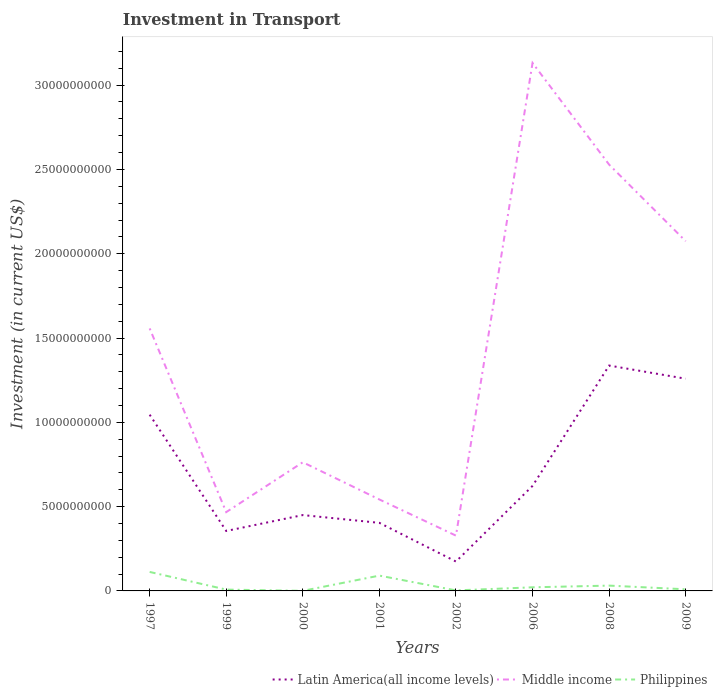How many different coloured lines are there?
Give a very brief answer. 3. Does the line corresponding to Middle income intersect with the line corresponding to Latin America(all income levels)?
Provide a succinct answer. No. Is the number of lines equal to the number of legend labels?
Provide a succinct answer. Yes. Across all years, what is the maximum amount invested in transport in Philippines?
Offer a terse response. 4.90e+06. In which year was the amount invested in transport in Middle income maximum?
Provide a succinct answer. 2002. What is the total amount invested in transport in Philippines in the graph?
Offer a very short reply. 2.18e+08. What is the difference between the highest and the second highest amount invested in transport in Middle income?
Offer a terse response. 2.80e+1. How many years are there in the graph?
Your response must be concise. 8. Are the values on the major ticks of Y-axis written in scientific E-notation?
Offer a terse response. No. Does the graph contain any zero values?
Make the answer very short. No. How many legend labels are there?
Give a very brief answer. 3. How are the legend labels stacked?
Provide a short and direct response. Horizontal. What is the title of the graph?
Make the answer very short. Investment in Transport. Does "Latin America(all income levels)" appear as one of the legend labels in the graph?
Keep it short and to the point. Yes. What is the label or title of the X-axis?
Your answer should be very brief. Years. What is the label or title of the Y-axis?
Your response must be concise. Investment (in current US$). What is the Investment (in current US$) of Latin America(all income levels) in 1997?
Make the answer very short. 1.05e+1. What is the Investment (in current US$) in Middle income in 1997?
Ensure brevity in your answer.  1.56e+1. What is the Investment (in current US$) in Philippines in 1997?
Offer a terse response. 1.13e+09. What is the Investment (in current US$) in Latin America(all income levels) in 1999?
Make the answer very short. 3.56e+09. What is the Investment (in current US$) of Middle income in 1999?
Provide a succinct answer. 4.67e+09. What is the Investment (in current US$) in Philippines in 1999?
Offer a terse response. 7.83e+07. What is the Investment (in current US$) in Latin America(all income levels) in 2000?
Offer a very short reply. 4.50e+09. What is the Investment (in current US$) in Middle income in 2000?
Ensure brevity in your answer.  7.63e+09. What is the Investment (in current US$) in Philippines in 2000?
Offer a terse response. 4.90e+06. What is the Investment (in current US$) of Latin America(all income levels) in 2001?
Give a very brief answer. 4.04e+09. What is the Investment (in current US$) of Middle income in 2001?
Make the answer very short. 5.42e+09. What is the Investment (in current US$) of Philippines in 2001?
Offer a very short reply. 9.08e+08. What is the Investment (in current US$) in Latin America(all income levels) in 2002?
Ensure brevity in your answer.  1.74e+09. What is the Investment (in current US$) in Middle income in 2002?
Offer a terse response. 3.28e+09. What is the Investment (in current US$) of Philippines in 2002?
Provide a succinct answer. 3.01e+07. What is the Investment (in current US$) of Latin America(all income levels) in 2006?
Ensure brevity in your answer.  6.23e+09. What is the Investment (in current US$) of Middle income in 2006?
Keep it short and to the point. 3.13e+1. What is the Investment (in current US$) of Philippines in 2006?
Provide a short and direct response. 2.15e+08. What is the Investment (in current US$) in Latin America(all income levels) in 2008?
Offer a very short reply. 1.34e+1. What is the Investment (in current US$) in Middle income in 2008?
Keep it short and to the point. 2.53e+1. What is the Investment (in current US$) of Philippines in 2008?
Provide a short and direct response. 3.15e+08. What is the Investment (in current US$) in Latin America(all income levels) in 2009?
Offer a very short reply. 1.26e+1. What is the Investment (in current US$) of Middle income in 2009?
Keep it short and to the point. 2.07e+1. What is the Investment (in current US$) of Philippines in 2009?
Your answer should be compact. 9.60e+07. Across all years, what is the maximum Investment (in current US$) of Latin America(all income levels)?
Offer a terse response. 1.34e+1. Across all years, what is the maximum Investment (in current US$) in Middle income?
Give a very brief answer. 3.13e+1. Across all years, what is the maximum Investment (in current US$) of Philippines?
Provide a short and direct response. 1.13e+09. Across all years, what is the minimum Investment (in current US$) of Latin America(all income levels)?
Your answer should be very brief. 1.74e+09. Across all years, what is the minimum Investment (in current US$) in Middle income?
Your response must be concise. 3.28e+09. Across all years, what is the minimum Investment (in current US$) of Philippines?
Give a very brief answer. 4.90e+06. What is the total Investment (in current US$) in Latin America(all income levels) in the graph?
Offer a very short reply. 5.65e+1. What is the total Investment (in current US$) in Middle income in the graph?
Offer a terse response. 1.14e+11. What is the total Investment (in current US$) in Philippines in the graph?
Your answer should be compact. 2.77e+09. What is the difference between the Investment (in current US$) in Latin America(all income levels) in 1997 and that in 1999?
Ensure brevity in your answer.  6.90e+09. What is the difference between the Investment (in current US$) of Middle income in 1997 and that in 1999?
Ensure brevity in your answer.  1.09e+1. What is the difference between the Investment (in current US$) of Philippines in 1997 and that in 1999?
Give a very brief answer. 1.05e+09. What is the difference between the Investment (in current US$) in Latin America(all income levels) in 1997 and that in 2000?
Make the answer very short. 5.95e+09. What is the difference between the Investment (in current US$) of Middle income in 1997 and that in 2000?
Provide a succinct answer. 7.94e+09. What is the difference between the Investment (in current US$) of Philippines in 1997 and that in 2000?
Offer a very short reply. 1.12e+09. What is the difference between the Investment (in current US$) of Latin America(all income levels) in 1997 and that in 2001?
Keep it short and to the point. 6.42e+09. What is the difference between the Investment (in current US$) of Middle income in 1997 and that in 2001?
Keep it short and to the point. 1.01e+1. What is the difference between the Investment (in current US$) in Philippines in 1997 and that in 2001?
Ensure brevity in your answer.  2.18e+08. What is the difference between the Investment (in current US$) of Latin America(all income levels) in 1997 and that in 2002?
Make the answer very short. 8.71e+09. What is the difference between the Investment (in current US$) in Middle income in 1997 and that in 2002?
Your response must be concise. 1.23e+1. What is the difference between the Investment (in current US$) of Philippines in 1997 and that in 2002?
Offer a very short reply. 1.10e+09. What is the difference between the Investment (in current US$) of Latin America(all income levels) in 1997 and that in 2006?
Give a very brief answer. 4.22e+09. What is the difference between the Investment (in current US$) in Middle income in 1997 and that in 2006?
Keep it short and to the point. -1.57e+1. What is the difference between the Investment (in current US$) of Philippines in 1997 and that in 2006?
Your answer should be compact. 9.12e+08. What is the difference between the Investment (in current US$) in Latin America(all income levels) in 1997 and that in 2008?
Ensure brevity in your answer.  -2.91e+09. What is the difference between the Investment (in current US$) of Middle income in 1997 and that in 2008?
Your answer should be very brief. -9.72e+09. What is the difference between the Investment (in current US$) of Philippines in 1997 and that in 2008?
Your answer should be very brief. 8.11e+08. What is the difference between the Investment (in current US$) of Latin America(all income levels) in 1997 and that in 2009?
Provide a succinct answer. -2.13e+09. What is the difference between the Investment (in current US$) in Middle income in 1997 and that in 2009?
Ensure brevity in your answer.  -5.18e+09. What is the difference between the Investment (in current US$) in Philippines in 1997 and that in 2009?
Your answer should be compact. 1.03e+09. What is the difference between the Investment (in current US$) of Latin America(all income levels) in 1999 and that in 2000?
Make the answer very short. -9.42e+08. What is the difference between the Investment (in current US$) of Middle income in 1999 and that in 2000?
Offer a very short reply. -2.96e+09. What is the difference between the Investment (in current US$) of Philippines in 1999 and that in 2000?
Your response must be concise. 7.34e+07. What is the difference between the Investment (in current US$) of Latin America(all income levels) in 1999 and that in 2001?
Offer a terse response. -4.81e+08. What is the difference between the Investment (in current US$) of Middle income in 1999 and that in 2001?
Offer a terse response. -7.49e+08. What is the difference between the Investment (in current US$) in Philippines in 1999 and that in 2001?
Provide a succinct answer. -8.30e+08. What is the difference between the Investment (in current US$) in Latin America(all income levels) in 1999 and that in 2002?
Ensure brevity in your answer.  1.81e+09. What is the difference between the Investment (in current US$) in Middle income in 1999 and that in 2002?
Make the answer very short. 1.40e+09. What is the difference between the Investment (in current US$) of Philippines in 1999 and that in 2002?
Make the answer very short. 4.82e+07. What is the difference between the Investment (in current US$) in Latin America(all income levels) in 1999 and that in 2006?
Offer a very short reply. -2.67e+09. What is the difference between the Investment (in current US$) of Middle income in 1999 and that in 2006?
Keep it short and to the point. -2.66e+1. What is the difference between the Investment (in current US$) of Philippines in 1999 and that in 2006?
Provide a succinct answer. -1.36e+08. What is the difference between the Investment (in current US$) in Latin America(all income levels) in 1999 and that in 2008?
Make the answer very short. -9.81e+09. What is the difference between the Investment (in current US$) of Middle income in 1999 and that in 2008?
Make the answer very short. -2.06e+1. What is the difference between the Investment (in current US$) in Philippines in 1999 and that in 2008?
Make the answer very short. -2.37e+08. What is the difference between the Investment (in current US$) of Latin America(all income levels) in 1999 and that in 2009?
Your answer should be very brief. -9.03e+09. What is the difference between the Investment (in current US$) in Middle income in 1999 and that in 2009?
Make the answer very short. -1.61e+1. What is the difference between the Investment (in current US$) of Philippines in 1999 and that in 2009?
Give a very brief answer. -1.77e+07. What is the difference between the Investment (in current US$) of Latin America(all income levels) in 2000 and that in 2001?
Ensure brevity in your answer.  4.62e+08. What is the difference between the Investment (in current US$) in Middle income in 2000 and that in 2001?
Your answer should be very brief. 2.21e+09. What is the difference between the Investment (in current US$) of Philippines in 2000 and that in 2001?
Offer a terse response. -9.04e+08. What is the difference between the Investment (in current US$) of Latin America(all income levels) in 2000 and that in 2002?
Your answer should be compact. 2.76e+09. What is the difference between the Investment (in current US$) of Middle income in 2000 and that in 2002?
Ensure brevity in your answer.  4.35e+09. What is the difference between the Investment (in current US$) in Philippines in 2000 and that in 2002?
Offer a very short reply. -2.52e+07. What is the difference between the Investment (in current US$) in Latin America(all income levels) in 2000 and that in 2006?
Make the answer very short. -1.73e+09. What is the difference between the Investment (in current US$) of Middle income in 2000 and that in 2006?
Provide a succinct answer. -2.37e+1. What is the difference between the Investment (in current US$) in Philippines in 2000 and that in 2006?
Keep it short and to the point. -2.10e+08. What is the difference between the Investment (in current US$) of Latin America(all income levels) in 2000 and that in 2008?
Your answer should be very brief. -8.87e+09. What is the difference between the Investment (in current US$) in Middle income in 2000 and that in 2008?
Your answer should be compact. -1.77e+1. What is the difference between the Investment (in current US$) of Philippines in 2000 and that in 2008?
Ensure brevity in your answer.  -3.10e+08. What is the difference between the Investment (in current US$) in Latin America(all income levels) in 2000 and that in 2009?
Make the answer very short. -8.09e+09. What is the difference between the Investment (in current US$) of Middle income in 2000 and that in 2009?
Give a very brief answer. -1.31e+1. What is the difference between the Investment (in current US$) of Philippines in 2000 and that in 2009?
Give a very brief answer. -9.11e+07. What is the difference between the Investment (in current US$) in Latin America(all income levels) in 2001 and that in 2002?
Your answer should be very brief. 2.29e+09. What is the difference between the Investment (in current US$) in Middle income in 2001 and that in 2002?
Offer a terse response. 2.14e+09. What is the difference between the Investment (in current US$) in Philippines in 2001 and that in 2002?
Give a very brief answer. 8.78e+08. What is the difference between the Investment (in current US$) of Latin America(all income levels) in 2001 and that in 2006?
Give a very brief answer. -2.19e+09. What is the difference between the Investment (in current US$) of Middle income in 2001 and that in 2006?
Give a very brief answer. -2.59e+1. What is the difference between the Investment (in current US$) in Philippines in 2001 and that in 2006?
Keep it short and to the point. 6.94e+08. What is the difference between the Investment (in current US$) in Latin America(all income levels) in 2001 and that in 2008?
Offer a terse response. -9.33e+09. What is the difference between the Investment (in current US$) of Middle income in 2001 and that in 2008?
Provide a succinct answer. -1.99e+1. What is the difference between the Investment (in current US$) of Philippines in 2001 and that in 2008?
Your response must be concise. 5.93e+08. What is the difference between the Investment (in current US$) in Latin America(all income levels) in 2001 and that in 2009?
Make the answer very short. -8.55e+09. What is the difference between the Investment (in current US$) in Middle income in 2001 and that in 2009?
Offer a terse response. -1.53e+1. What is the difference between the Investment (in current US$) of Philippines in 2001 and that in 2009?
Give a very brief answer. 8.12e+08. What is the difference between the Investment (in current US$) in Latin America(all income levels) in 2002 and that in 2006?
Your response must be concise. -4.49e+09. What is the difference between the Investment (in current US$) in Middle income in 2002 and that in 2006?
Your answer should be very brief. -2.80e+1. What is the difference between the Investment (in current US$) of Philippines in 2002 and that in 2006?
Make the answer very short. -1.84e+08. What is the difference between the Investment (in current US$) of Latin America(all income levels) in 2002 and that in 2008?
Offer a very short reply. -1.16e+1. What is the difference between the Investment (in current US$) of Middle income in 2002 and that in 2008?
Ensure brevity in your answer.  -2.20e+1. What is the difference between the Investment (in current US$) in Philippines in 2002 and that in 2008?
Keep it short and to the point. -2.85e+08. What is the difference between the Investment (in current US$) of Latin America(all income levels) in 2002 and that in 2009?
Your response must be concise. -1.08e+1. What is the difference between the Investment (in current US$) in Middle income in 2002 and that in 2009?
Ensure brevity in your answer.  -1.75e+1. What is the difference between the Investment (in current US$) of Philippines in 2002 and that in 2009?
Ensure brevity in your answer.  -6.59e+07. What is the difference between the Investment (in current US$) in Latin America(all income levels) in 2006 and that in 2008?
Provide a succinct answer. -7.14e+09. What is the difference between the Investment (in current US$) of Middle income in 2006 and that in 2008?
Make the answer very short. 6.03e+09. What is the difference between the Investment (in current US$) of Philippines in 2006 and that in 2008?
Your answer should be compact. -1.01e+08. What is the difference between the Investment (in current US$) of Latin America(all income levels) in 2006 and that in 2009?
Provide a succinct answer. -6.36e+09. What is the difference between the Investment (in current US$) of Middle income in 2006 and that in 2009?
Your answer should be very brief. 1.06e+1. What is the difference between the Investment (in current US$) of Philippines in 2006 and that in 2009?
Your answer should be very brief. 1.19e+08. What is the difference between the Investment (in current US$) of Latin America(all income levels) in 2008 and that in 2009?
Offer a terse response. 7.81e+08. What is the difference between the Investment (in current US$) in Middle income in 2008 and that in 2009?
Offer a terse response. 4.54e+09. What is the difference between the Investment (in current US$) of Philippines in 2008 and that in 2009?
Provide a succinct answer. 2.19e+08. What is the difference between the Investment (in current US$) in Latin America(all income levels) in 1997 and the Investment (in current US$) in Middle income in 1999?
Keep it short and to the point. 5.78e+09. What is the difference between the Investment (in current US$) of Latin America(all income levels) in 1997 and the Investment (in current US$) of Philippines in 1999?
Provide a succinct answer. 1.04e+1. What is the difference between the Investment (in current US$) in Middle income in 1997 and the Investment (in current US$) in Philippines in 1999?
Your answer should be compact. 1.55e+1. What is the difference between the Investment (in current US$) in Latin America(all income levels) in 1997 and the Investment (in current US$) in Middle income in 2000?
Offer a very short reply. 2.82e+09. What is the difference between the Investment (in current US$) in Latin America(all income levels) in 1997 and the Investment (in current US$) in Philippines in 2000?
Offer a terse response. 1.04e+1. What is the difference between the Investment (in current US$) of Middle income in 1997 and the Investment (in current US$) of Philippines in 2000?
Make the answer very short. 1.56e+1. What is the difference between the Investment (in current US$) of Latin America(all income levels) in 1997 and the Investment (in current US$) of Middle income in 2001?
Your response must be concise. 5.03e+09. What is the difference between the Investment (in current US$) of Latin America(all income levels) in 1997 and the Investment (in current US$) of Philippines in 2001?
Your answer should be compact. 9.54e+09. What is the difference between the Investment (in current US$) of Middle income in 1997 and the Investment (in current US$) of Philippines in 2001?
Keep it short and to the point. 1.47e+1. What is the difference between the Investment (in current US$) in Latin America(all income levels) in 1997 and the Investment (in current US$) in Middle income in 2002?
Offer a very short reply. 7.17e+09. What is the difference between the Investment (in current US$) in Latin America(all income levels) in 1997 and the Investment (in current US$) in Philippines in 2002?
Your answer should be compact. 1.04e+1. What is the difference between the Investment (in current US$) in Middle income in 1997 and the Investment (in current US$) in Philippines in 2002?
Your answer should be very brief. 1.55e+1. What is the difference between the Investment (in current US$) in Latin America(all income levels) in 1997 and the Investment (in current US$) in Middle income in 2006?
Make the answer very short. -2.09e+1. What is the difference between the Investment (in current US$) of Latin America(all income levels) in 1997 and the Investment (in current US$) of Philippines in 2006?
Your response must be concise. 1.02e+1. What is the difference between the Investment (in current US$) in Middle income in 1997 and the Investment (in current US$) in Philippines in 2006?
Make the answer very short. 1.54e+1. What is the difference between the Investment (in current US$) in Latin America(all income levels) in 1997 and the Investment (in current US$) in Middle income in 2008?
Give a very brief answer. -1.48e+1. What is the difference between the Investment (in current US$) in Latin America(all income levels) in 1997 and the Investment (in current US$) in Philippines in 2008?
Make the answer very short. 1.01e+1. What is the difference between the Investment (in current US$) of Middle income in 1997 and the Investment (in current US$) of Philippines in 2008?
Provide a short and direct response. 1.53e+1. What is the difference between the Investment (in current US$) in Latin America(all income levels) in 1997 and the Investment (in current US$) in Middle income in 2009?
Your answer should be compact. -1.03e+1. What is the difference between the Investment (in current US$) in Latin America(all income levels) in 1997 and the Investment (in current US$) in Philippines in 2009?
Give a very brief answer. 1.04e+1. What is the difference between the Investment (in current US$) of Middle income in 1997 and the Investment (in current US$) of Philippines in 2009?
Your response must be concise. 1.55e+1. What is the difference between the Investment (in current US$) in Latin America(all income levels) in 1999 and the Investment (in current US$) in Middle income in 2000?
Make the answer very short. -4.07e+09. What is the difference between the Investment (in current US$) of Latin America(all income levels) in 1999 and the Investment (in current US$) of Philippines in 2000?
Make the answer very short. 3.55e+09. What is the difference between the Investment (in current US$) in Middle income in 1999 and the Investment (in current US$) in Philippines in 2000?
Your answer should be compact. 4.67e+09. What is the difference between the Investment (in current US$) of Latin America(all income levels) in 1999 and the Investment (in current US$) of Middle income in 2001?
Provide a succinct answer. -1.87e+09. What is the difference between the Investment (in current US$) of Latin America(all income levels) in 1999 and the Investment (in current US$) of Philippines in 2001?
Your answer should be compact. 2.65e+09. What is the difference between the Investment (in current US$) in Middle income in 1999 and the Investment (in current US$) in Philippines in 2001?
Give a very brief answer. 3.77e+09. What is the difference between the Investment (in current US$) in Latin America(all income levels) in 1999 and the Investment (in current US$) in Middle income in 2002?
Ensure brevity in your answer.  2.78e+08. What is the difference between the Investment (in current US$) of Latin America(all income levels) in 1999 and the Investment (in current US$) of Philippines in 2002?
Ensure brevity in your answer.  3.53e+09. What is the difference between the Investment (in current US$) of Middle income in 1999 and the Investment (in current US$) of Philippines in 2002?
Your response must be concise. 4.64e+09. What is the difference between the Investment (in current US$) in Latin America(all income levels) in 1999 and the Investment (in current US$) in Middle income in 2006?
Keep it short and to the point. -2.78e+1. What is the difference between the Investment (in current US$) of Latin America(all income levels) in 1999 and the Investment (in current US$) of Philippines in 2006?
Keep it short and to the point. 3.34e+09. What is the difference between the Investment (in current US$) in Middle income in 1999 and the Investment (in current US$) in Philippines in 2006?
Your answer should be very brief. 4.46e+09. What is the difference between the Investment (in current US$) of Latin America(all income levels) in 1999 and the Investment (in current US$) of Middle income in 2008?
Make the answer very short. -2.17e+1. What is the difference between the Investment (in current US$) in Latin America(all income levels) in 1999 and the Investment (in current US$) in Philippines in 2008?
Provide a short and direct response. 3.24e+09. What is the difference between the Investment (in current US$) of Middle income in 1999 and the Investment (in current US$) of Philippines in 2008?
Give a very brief answer. 4.36e+09. What is the difference between the Investment (in current US$) of Latin America(all income levels) in 1999 and the Investment (in current US$) of Middle income in 2009?
Offer a terse response. -1.72e+1. What is the difference between the Investment (in current US$) in Latin America(all income levels) in 1999 and the Investment (in current US$) in Philippines in 2009?
Offer a very short reply. 3.46e+09. What is the difference between the Investment (in current US$) in Middle income in 1999 and the Investment (in current US$) in Philippines in 2009?
Provide a short and direct response. 4.58e+09. What is the difference between the Investment (in current US$) of Latin America(all income levels) in 2000 and the Investment (in current US$) of Middle income in 2001?
Provide a succinct answer. -9.25e+08. What is the difference between the Investment (in current US$) of Latin America(all income levels) in 2000 and the Investment (in current US$) of Philippines in 2001?
Make the answer very short. 3.59e+09. What is the difference between the Investment (in current US$) of Middle income in 2000 and the Investment (in current US$) of Philippines in 2001?
Your response must be concise. 6.72e+09. What is the difference between the Investment (in current US$) in Latin America(all income levels) in 2000 and the Investment (in current US$) in Middle income in 2002?
Give a very brief answer. 1.22e+09. What is the difference between the Investment (in current US$) in Latin America(all income levels) in 2000 and the Investment (in current US$) in Philippines in 2002?
Your answer should be compact. 4.47e+09. What is the difference between the Investment (in current US$) of Middle income in 2000 and the Investment (in current US$) of Philippines in 2002?
Provide a short and direct response. 7.60e+09. What is the difference between the Investment (in current US$) of Latin America(all income levels) in 2000 and the Investment (in current US$) of Middle income in 2006?
Provide a short and direct response. -2.68e+1. What is the difference between the Investment (in current US$) of Latin America(all income levels) in 2000 and the Investment (in current US$) of Philippines in 2006?
Offer a very short reply. 4.28e+09. What is the difference between the Investment (in current US$) in Middle income in 2000 and the Investment (in current US$) in Philippines in 2006?
Your answer should be very brief. 7.42e+09. What is the difference between the Investment (in current US$) in Latin America(all income levels) in 2000 and the Investment (in current US$) in Middle income in 2008?
Your response must be concise. -2.08e+1. What is the difference between the Investment (in current US$) in Latin America(all income levels) in 2000 and the Investment (in current US$) in Philippines in 2008?
Your answer should be very brief. 4.18e+09. What is the difference between the Investment (in current US$) of Middle income in 2000 and the Investment (in current US$) of Philippines in 2008?
Offer a terse response. 7.32e+09. What is the difference between the Investment (in current US$) in Latin America(all income levels) in 2000 and the Investment (in current US$) in Middle income in 2009?
Your response must be concise. -1.62e+1. What is the difference between the Investment (in current US$) of Latin America(all income levels) in 2000 and the Investment (in current US$) of Philippines in 2009?
Your response must be concise. 4.40e+09. What is the difference between the Investment (in current US$) in Middle income in 2000 and the Investment (in current US$) in Philippines in 2009?
Give a very brief answer. 7.53e+09. What is the difference between the Investment (in current US$) in Latin America(all income levels) in 2001 and the Investment (in current US$) in Middle income in 2002?
Provide a short and direct response. 7.58e+08. What is the difference between the Investment (in current US$) in Latin America(all income levels) in 2001 and the Investment (in current US$) in Philippines in 2002?
Your answer should be compact. 4.01e+09. What is the difference between the Investment (in current US$) of Middle income in 2001 and the Investment (in current US$) of Philippines in 2002?
Give a very brief answer. 5.39e+09. What is the difference between the Investment (in current US$) of Latin America(all income levels) in 2001 and the Investment (in current US$) of Middle income in 2006?
Your response must be concise. -2.73e+1. What is the difference between the Investment (in current US$) in Latin America(all income levels) in 2001 and the Investment (in current US$) in Philippines in 2006?
Your answer should be compact. 3.82e+09. What is the difference between the Investment (in current US$) in Middle income in 2001 and the Investment (in current US$) in Philippines in 2006?
Your answer should be compact. 5.21e+09. What is the difference between the Investment (in current US$) of Latin America(all income levels) in 2001 and the Investment (in current US$) of Middle income in 2008?
Give a very brief answer. -2.12e+1. What is the difference between the Investment (in current US$) of Latin America(all income levels) in 2001 and the Investment (in current US$) of Philippines in 2008?
Provide a succinct answer. 3.72e+09. What is the difference between the Investment (in current US$) in Middle income in 2001 and the Investment (in current US$) in Philippines in 2008?
Give a very brief answer. 5.11e+09. What is the difference between the Investment (in current US$) of Latin America(all income levels) in 2001 and the Investment (in current US$) of Middle income in 2009?
Keep it short and to the point. -1.67e+1. What is the difference between the Investment (in current US$) in Latin America(all income levels) in 2001 and the Investment (in current US$) in Philippines in 2009?
Give a very brief answer. 3.94e+09. What is the difference between the Investment (in current US$) of Middle income in 2001 and the Investment (in current US$) of Philippines in 2009?
Your response must be concise. 5.33e+09. What is the difference between the Investment (in current US$) in Latin America(all income levels) in 2002 and the Investment (in current US$) in Middle income in 2006?
Your answer should be very brief. -2.96e+1. What is the difference between the Investment (in current US$) of Latin America(all income levels) in 2002 and the Investment (in current US$) of Philippines in 2006?
Offer a very short reply. 1.53e+09. What is the difference between the Investment (in current US$) of Middle income in 2002 and the Investment (in current US$) of Philippines in 2006?
Provide a succinct answer. 3.06e+09. What is the difference between the Investment (in current US$) in Latin America(all income levels) in 2002 and the Investment (in current US$) in Middle income in 2008?
Give a very brief answer. -2.35e+1. What is the difference between the Investment (in current US$) in Latin America(all income levels) in 2002 and the Investment (in current US$) in Philippines in 2008?
Your response must be concise. 1.43e+09. What is the difference between the Investment (in current US$) of Middle income in 2002 and the Investment (in current US$) of Philippines in 2008?
Your response must be concise. 2.96e+09. What is the difference between the Investment (in current US$) of Latin America(all income levels) in 2002 and the Investment (in current US$) of Middle income in 2009?
Your answer should be very brief. -1.90e+1. What is the difference between the Investment (in current US$) in Latin America(all income levels) in 2002 and the Investment (in current US$) in Philippines in 2009?
Ensure brevity in your answer.  1.65e+09. What is the difference between the Investment (in current US$) of Middle income in 2002 and the Investment (in current US$) of Philippines in 2009?
Your answer should be very brief. 3.18e+09. What is the difference between the Investment (in current US$) in Latin America(all income levels) in 2006 and the Investment (in current US$) in Middle income in 2008?
Your response must be concise. -1.91e+1. What is the difference between the Investment (in current US$) in Latin America(all income levels) in 2006 and the Investment (in current US$) in Philippines in 2008?
Your answer should be very brief. 5.91e+09. What is the difference between the Investment (in current US$) in Middle income in 2006 and the Investment (in current US$) in Philippines in 2008?
Offer a very short reply. 3.10e+1. What is the difference between the Investment (in current US$) of Latin America(all income levels) in 2006 and the Investment (in current US$) of Middle income in 2009?
Ensure brevity in your answer.  -1.45e+1. What is the difference between the Investment (in current US$) of Latin America(all income levels) in 2006 and the Investment (in current US$) of Philippines in 2009?
Make the answer very short. 6.13e+09. What is the difference between the Investment (in current US$) of Middle income in 2006 and the Investment (in current US$) of Philippines in 2009?
Your answer should be compact. 3.12e+1. What is the difference between the Investment (in current US$) of Latin America(all income levels) in 2008 and the Investment (in current US$) of Middle income in 2009?
Offer a terse response. -7.38e+09. What is the difference between the Investment (in current US$) in Latin America(all income levels) in 2008 and the Investment (in current US$) in Philippines in 2009?
Ensure brevity in your answer.  1.33e+1. What is the difference between the Investment (in current US$) in Middle income in 2008 and the Investment (in current US$) in Philippines in 2009?
Your response must be concise. 2.52e+1. What is the average Investment (in current US$) in Latin America(all income levels) per year?
Ensure brevity in your answer.  7.06e+09. What is the average Investment (in current US$) in Middle income per year?
Provide a short and direct response. 1.42e+1. What is the average Investment (in current US$) of Philippines per year?
Keep it short and to the point. 3.47e+08. In the year 1997, what is the difference between the Investment (in current US$) in Latin America(all income levels) and Investment (in current US$) in Middle income?
Your answer should be compact. -5.12e+09. In the year 1997, what is the difference between the Investment (in current US$) of Latin America(all income levels) and Investment (in current US$) of Philippines?
Your response must be concise. 9.33e+09. In the year 1997, what is the difference between the Investment (in current US$) in Middle income and Investment (in current US$) in Philippines?
Keep it short and to the point. 1.44e+1. In the year 1999, what is the difference between the Investment (in current US$) in Latin America(all income levels) and Investment (in current US$) in Middle income?
Provide a short and direct response. -1.12e+09. In the year 1999, what is the difference between the Investment (in current US$) of Latin America(all income levels) and Investment (in current US$) of Philippines?
Ensure brevity in your answer.  3.48e+09. In the year 1999, what is the difference between the Investment (in current US$) of Middle income and Investment (in current US$) of Philippines?
Offer a terse response. 4.60e+09. In the year 2000, what is the difference between the Investment (in current US$) of Latin America(all income levels) and Investment (in current US$) of Middle income?
Offer a terse response. -3.13e+09. In the year 2000, what is the difference between the Investment (in current US$) of Latin America(all income levels) and Investment (in current US$) of Philippines?
Your response must be concise. 4.49e+09. In the year 2000, what is the difference between the Investment (in current US$) of Middle income and Investment (in current US$) of Philippines?
Make the answer very short. 7.63e+09. In the year 2001, what is the difference between the Investment (in current US$) in Latin America(all income levels) and Investment (in current US$) in Middle income?
Provide a succinct answer. -1.39e+09. In the year 2001, what is the difference between the Investment (in current US$) in Latin America(all income levels) and Investment (in current US$) in Philippines?
Keep it short and to the point. 3.13e+09. In the year 2001, what is the difference between the Investment (in current US$) in Middle income and Investment (in current US$) in Philippines?
Keep it short and to the point. 4.52e+09. In the year 2002, what is the difference between the Investment (in current US$) of Latin America(all income levels) and Investment (in current US$) of Middle income?
Provide a succinct answer. -1.54e+09. In the year 2002, what is the difference between the Investment (in current US$) of Latin America(all income levels) and Investment (in current US$) of Philippines?
Keep it short and to the point. 1.71e+09. In the year 2002, what is the difference between the Investment (in current US$) of Middle income and Investment (in current US$) of Philippines?
Your answer should be compact. 3.25e+09. In the year 2006, what is the difference between the Investment (in current US$) of Latin America(all income levels) and Investment (in current US$) of Middle income?
Keep it short and to the point. -2.51e+1. In the year 2006, what is the difference between the Investment (in current US$) of Latin America(all income levels) and Investment (in current US$) of Philippines?
Your answer should be very brief. 6.02e+09. In the year 2006, what is the difference between the Investment (in current US$) in Middle income and Investment (in current US$) in Philippines?
Ensure brevity in your answer.  3.11e+1. In the year 2008, what is the difference between the Investment (in current US$) in Latin America(all income levels) and Investment (in current US$) in Middle income?
Offer a very short reply. -1.19e+1. In the year 2008, what is the difference between the Investment (in current US$) of Latin America(all income levels) and Investment (in current US$) of Philippines?
Make the answer very short. 1.31e+1. In the year 2008, what is the difference between the Investment (in current US$) of Middle income and Investment (in current US$) of Philippines?
Offer a very short reply. 2.50e+1. In the year 2009, what is the difference between the Investment (in current US$) in Latin America(all income levels) and Investment (in current US$) in Middle income?
Provide a short and direct response. -8.16e+09. In the year 2009, what is the difference between the Investment (in current US$) of Latin America(all income levels) and Investment (in current US$) of Philippines?
Offer a very short reply. 1.25e+1. In the year 2009, what is the difference between the Investment (in current US$) of Middle income and Investment (in current US$) of Philippines?
Offer a very short reply. 2.06e+1. What is the ratio of the Investment (in current US$) of Latin America(all income levels) in 1997 to that in 1999?
Provide a succinct answer. 2.94. What is the ratio of the Investment (in current US$) of Middle income in 1997 to that in 1999?
Provide a succinct answer. 3.33. What is the ratio of the Investment (in current US$) in Philippines in 1997 to that in 1999?
Make the answer very short. 14.39. What is the ratio of the Investment (in current US$) in Latin America(all income levels) in 1997 to that in 2000?
Your response must be concise. 2.32. What is the ratio of the Investment (in current US$) of Middle income in 1997 to that in 2000?
Provide a succinct answer. 2.04. What is the ratio of the Investment (in current US$) of Philippines in 1997 to that in 2000?
Provide a succinct answer. 229.94. What is the ratio of the Investment (in current US$) of Latin America(all income levels) in 1997 to that in 2001?
Ensure brevity in your answer.  2.59. What is the ratio of the Investment (in current US$) in Middle income in 1997 to that in 2001?
Keep it short and to the point. 2.87. What is the ratio of the Investment (in current US$) in Philippines in 1997 to that in 2001?
Your response must be concise. 1.24. What is the ratio of the Investment (in current US$) in Latin America(all income levels) in 1997 to that in 2002?
Provide a succinct answer. 6. What is the ratio of the Investment (in current US$) in Middle income in 1997 to that in 2002?
Make the answer very short. 4.75. What is the ratio of the Investment (in current US$) of Philippines in 1997 to that in 2002?
Provide a short and direct response. 37.43. What is the ratio of the Investment (in current US$) in Latin America(all income levels) in 1997 to that in 2006?
Provide a succinct answer. 1.68. What is the ratio of the Investment (in current US$) of Middle income in 1997 to that in 2006?
Give a very brief answer. 0.5. What is the ratio of the Investment (in current US$) in Philippines in 1997 to that in 2006?
Your answer should be very brief. 5.25. What is the ratio of the Investment (in current US$) of Latin America(all income levels) in 1997 to that in 2008?
Your answer should be compact. 0.78. What is the ratio of the Investment (in current US$) of Middle income in 1997 to that in 2008?
Your answer should be compact. 0.62. What is the ratio of the Investment (in current US$) of Philippines in 1997 to that in 2008?
Ensure brevity in your answer.  3.57. What is the ratio of the Investment (in current US$) in Latin America(all income levels) in 1997 to that in 2009?
Provide a succinct answer. 0.83. What is the ratio of the Investment (in current US$) of Middle income in 1997 to that in 2009?
Keep it short and to the point. 0.75. What is the ratio of the Investment (in current US$) of Philippines in 1997 to that in 2009?
Provide a short and direct response. 11.74. What is the ratio of the Investment (in current US$) of Latin America(all income levels) in 1999 to that in 2000?
Make the answer very short. 0.79. What is the ratio of the Investment (in current US$) of Middle income in 1999 to that in 2000?
Keep it short and to the point. 0.61. What is the ratio of the Investment (in current US$) in Philippines in 1999 to that in 2000?
Provide a short and direct response. 15.98. What is the ratio of the Investment (in current US$) of Latin America(all income levels) in 1999 to that in 2001?
Offer a very short reply. 0.88. What is the ratio of the Investment (in current US$) in Middle income in 1999 to that in 2001?
Provide a short and direct response. 0.86. What is the ratio of the Investment (in current US$) in Philippines in 1999 to that in 2001?
Provide a succinct answer. 0.09. What is the ratio of the Investment (in current US$) in Latin America(all income levels) in 1999 to that in 2002?
Your answer should be compact. 2.04. What is the ratio of the Investment (in current US$) of Middle income in 1999 to that in 2002?
Offer a terse response. 1.43. What is the ratio of the Investment (in current US$) of Philippines in 1999 to that in 2002?
Your answer should be compact. 2.6. What is the ratio of the Investment (in current US$) of Latin America(all income levels) in 1999 to that in 2006?
Provide a succinct answer. 0.57. What is the ratio of the Investment (in current US$) of Middle income in 1999 to that in 2006?
Keep it short and to the point. 0.15. What is the ratio of the Investment (in current US$) in Philippines in 1999 to that in 2006?
Your response must be concise. 0.36. What is the ratio of the Investment (in current US$) of Latin America(all income levels) in 1999 to that in 2008?
Your answer should be very brief. 0.27. What is the ratio of the Investment (in current US$) in Middle income in 1999 to that in 2008?
Offer a very short reply. 0.18. What is the ratio of the Investment (in current US$) in Philippines in 1999 to that in 2008?
Provide a short and direct response. 0.25. What is the ratio of the Investment (in current US$) of Latin America(all income levels) in 1999 to that in 2009?
Give a very brief answer. 0.28. What is the ratio of the Investment (in current US$) in Middle income in 1999 to that in 2009?
Your answer should be compact. 0.23. What is the ratio of the Investment (in current US$) in Philippines in 1999 to that in 2009?
Your answer should be compact. 0.82. What is the ratio of the Investment (in current US$) of Latin America(all income levels) in 2000 to that in 2001?
Your response must be concise. 1.11. What is the ratio of the Investment (in current US$) of Middle income in 2000 to that in 2001?
Provide a short and direct response. 1.41. What is the ratio of the Investment (in current US$) of Philippines in 2000 to that in 2001?
Provide a succinct answer. 0.01. What is the ratio of the Investment (in current US$) of Latin America(all income levels) in 2000 to that in 2002?
Keep it short and to the point. 2.58. What is the ratio of the Investment (in current US$) in Middle income in 2000 to that in 2002?
Offer a very short reply. 2.33. What is the ratio of the Investment (in current US$) in Philippines in 2000 to that in 2002?
Provide a succinct answer. 0.16. What is the ratio of the Investment (in current US$) of Latin America(all income levels) in 2000 to that in 2006?
Ensure brevity in your answer.  0.72. What is the ratio of the Investment (in current US$) in Middle income in 2000 to that in 2006?
Ensure brevity in your answer.  0.24. What is the ratio of the Investment (in current US$) in Philippines in 2000 to that in 2006?
Your response must be concise. 0.02. What is the ratio of the Investment (in current US$) of Latin America(all income levels) in 2000 to that in 2008?
Offer a very short reply. 0.34. What is the ratio of the Investment (in current US$) in Middle income in 2000 to that in 2008?
Your answer should be very brief. 0.3. What is the ratio of the Investment (in current US$) in Philippines in 2000 to that in 2008?
Ensure brevity in your answer.  0.02. What is the ratio of the Investment (in current US$) in Latin America(all income levels) in 2000 to that in 2009?
Keep it short and to the point. 0.36. What is the ratio of the Investment (in current US$) in Middle income in 2000 to that in 2009?
Keep it short and to the point. 0.37. What is the ratio of the Investment (in current US$) in Philippines in 2000 to that in 2009?
Your answer should be very brief. 0.05. What is the ratio of the Investment (in current US$) in Latin America(all income levels) in 2001 to that in 2002?
Your answer should be very brief. 2.32. What is the ratio of the Investment (in current US$) of Middle income in 2001 to that in 2002?
Offer a very short reply. 1.65. What is the ratio of the Investment (in current US$) of Philippines in 2001 to that in 2002?
Make the answer very short. 30.18. What is the ratio of the Investment (in current US$) of Latin America(all income levels) in 2001 to that in 2006?
Provide a succinct answer. 0.65. What is the ratio of the Investment (in current US$) of Middle income in 2001 to that in 2006?
Your answer should be compact. 0.17. What is the ratio of the Investment (in current US$) of Philippines in 2001 to that in 2006?
Provide a succinct answer. 4.23. What is the ratio of the Investment (in current US$) of Latin America(all income levels) in 2001 to that in 2008?
Your answer should be very brief. 0.3. What is the ratio of the Investment (in current US$) of Middle income in 2001 to that in 2008?
Make the answer very short. 0.21. What is the ratio of the Investment (in current US$) in Philippines in 2001 to that in 2008?
Provide a short and direct response. 2.88. What is the ratio of the Investment (in current US$) in Latin America(all income levels) in 2001 to that in 2009?
Make the answer very short. 0.32. What is the ratio of the Investment (in current US$) of Middle income in 2001 to that in 2009?
Provide a succinct answer. 0.26. What is the ratio of the Investment (in current US$) in Philippines in 2001 to that in 2009?
Give a very brief answer. 9.46. What is the ratio of the Investment (in current US$) in Latin America(all income levels) in 2002 to that in 2006?
Ensure brevity in your answer.  0.28. What is the ratio of the Investment (in current US$) in Middle income in 2002 to that in 2006?
Make the answer very short. 0.1. What is the ratio of the Investment (in current US$) of Philippines in 2002 to that in 2006?
Your answer should be very brief. 0.14. What is the ratio of the Investment (in current US$) of Latin America(all income levels) in 2002 to that in 2008?
Offer a very short reply. 0.13. What is the ratio of the Investment (in current US$) in Middle income in 2002 to that in 2008?
Provide a succinct answer. 0.13. What is the ratio of the Investment (in current US$) of Philippines in 2002 to that in 2008?
Keep it short and to the point. 0.1. What is the ratio of the Investment (in current US$) of Latin America(all income levels) in 2002 to that in 2009?
Provide a short and direct response. 0.14. What is the ratio of the Investment (in current US$) in Middle income in 2002 to that in 2009?
Offer a very short reply. 0.16. What is the ratio of the Investment (in current US$) of Philippines in 2002 to that in 2009?
Make the answer very short. 0.31. What is the ratio of the Investment (in current US$) in Latin America(all income levels) in 2006 to that in 2008?
Your answer should be compact. 0.47. What is the ratio of the Investment (in current US$) in Middle income in 2006 to that in 2008?
Provide a succinct answer. 1.24. What is the ratio of the Investment (in current US$) of Philippines in 2006 to that in 2008?
Offer a terse response. 0.68. What is the ratio of the Investment (in current US$) of Latin America(all income levels) in 2006 to that in 2009?
Your answer should be compact. 0.49. What is the ratio of the Investment (in current US$) of Middle income in 2006 to that in 2009?
Your answer should be very brief. 1.51. What is the ratio of the Investment (in current US$) in Philippines in 2006 to that in 2009?
Your answer should be compact. 2.24. What is the ratio of the Investment (in current US$) in Latin America(all income levels) in 2008 to that in 2009?
Provide a succinct answer. 1.06. What is the ratio of the Investment (in current US$) of Middle income in 2008 to that in 2009?
Ensure brevity in your answer.  1.22. What is the ratio of the Investment (in current US$) in Philippines in 2008 to that in 2009?
Your answer should be compact. 3.28. What is the difference between the highest and the second highest Investment (in current US$) of Latin America(all income levels)?
Your answer should be very brief. 7.81e+08. What is the difference between the highest and the second highest Investment (in current US$) of Middle income?
Ensure brevity in your answer.  6.03e+09. What is the difference between the highest and the second highest Investment (in current US$) in Philippines?
Offer a very short reply. 2.18e+08. What is the difference between the highest and the lowest Investment (in current US$) of Latin America(all income levels)?
Give a very brief answer. 1.16e+1. What is the difference between the highest and the lowest Investment (in current US$) of Middle income?
Offer a terse response. 2.80e+1. What is the difference between the highest and the lowest Investment (in current US$) in Philippines?
Your response must be concise. 1.12e+09. 